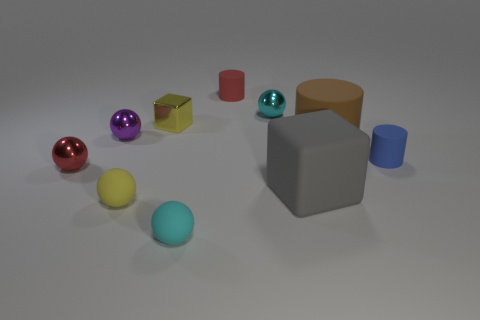What material is the object that is the same color as the tiny shiny block?
Ensure brevity in your answer.  Rubber. There is a cyan shiny sphere; how many red objects are behind it?
Your response must be concise. 1. Are the tiny yellow ball and the blue object made of the same material?
Your answer should be compact. Yes. How many tiny cyan things are both in front of the rubber block and right of the tiny red matte cylinder?
Make the answer very short. 0. What number of other things are the same color as the large matte cylinder?
Provide a short and direct response. 0. How many red objects are tiny shiny things or small blocks?
Offer a terse response. 1. The yellow sphere is what size?
Ensure brevity in your answer.  Small. How many matte things are either tiny cyan things or brown cylinders?
Your answer should be compact. 2. Is the number of yellow matte spheres less than the number of large brown balls?
Provide a succinct answer. No. How many other objects are the same material as the big cube?
Your response must be concise. 5. 